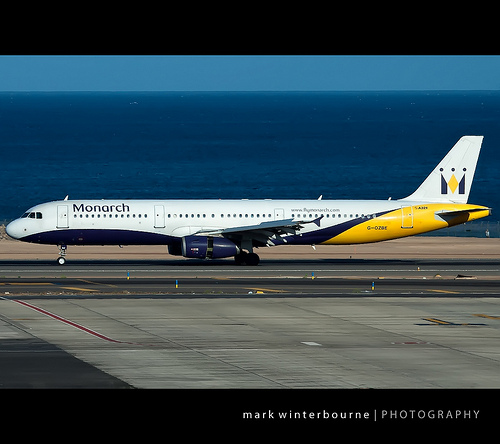Please provide the bounding box coordinate of the region this sentence describes: airport runway with white line down the middle. The region spans from [0.0, 0.58, 1.0, 0.61], which covers the runway with a white line in the middle. 